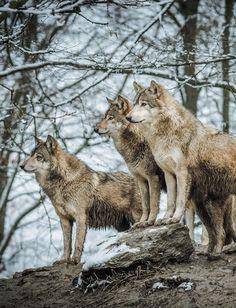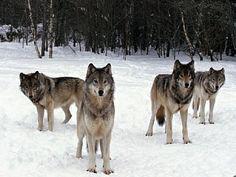The first image is the image on the left, the second image is the image on the right. For the images displayed, is the sentence "There are fewer than four wolves." factually correct? Answer yes or no. No. The first image is the image on the left, the second image is the image on the right. Considering the images on both sides, is "The left image includes a dog moving forward over snow toward the camera, and it includes a dog with an open mouth." valid? Answer yes or no. No. 